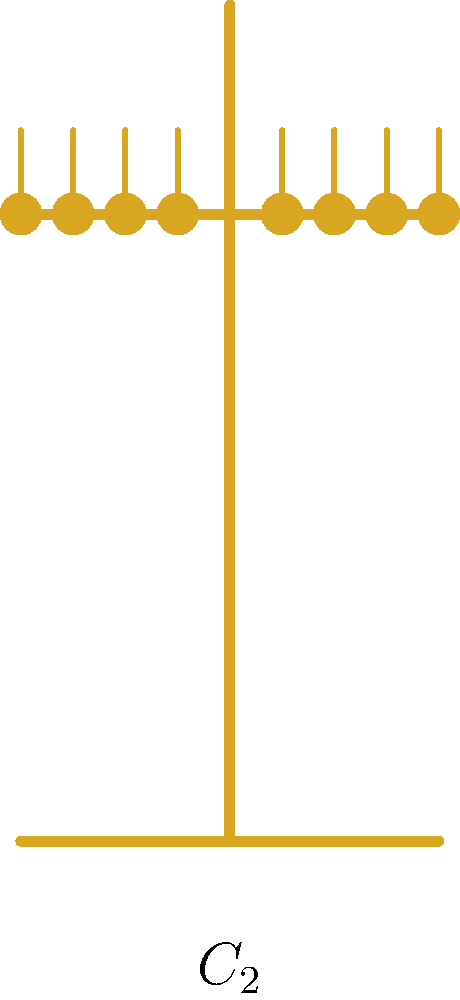Consider the menorah shown in the diagram, which has 8 candles arranged symmetrically around a central stem. What is the order of the rotational symmetry group of this menorah? Express your answer in terms of the cyclic group $C_n$. To determine the order of the rotational symmetry group, we need to consider the following steps:

1) First, observe that the menorah has a vertical axis of symmetry through its center.

2) The menorah can be rotated 180° (or π radians) about this axis, and it will look the same as the original position.

3) This rotation of 180° is the only non-trivial rotation that preserves the arrangement of the candles.

4) The identity transformation (rotation by 0° or 360°) is always a symmetry.

5) Therefore, there are two elements in the rotational symmetry group: the identity and the 180° rotation.

6) A group with two elements, where one element is the identity and the other is its own inverse, is isomorphic to the cyclic group of order 2, denoted as $C_2$.

7) The $C_2$ group represents rotations by 0° and 180°, which are precisely the rotational symmetries of the menorah.
Answer: $C_2$ 